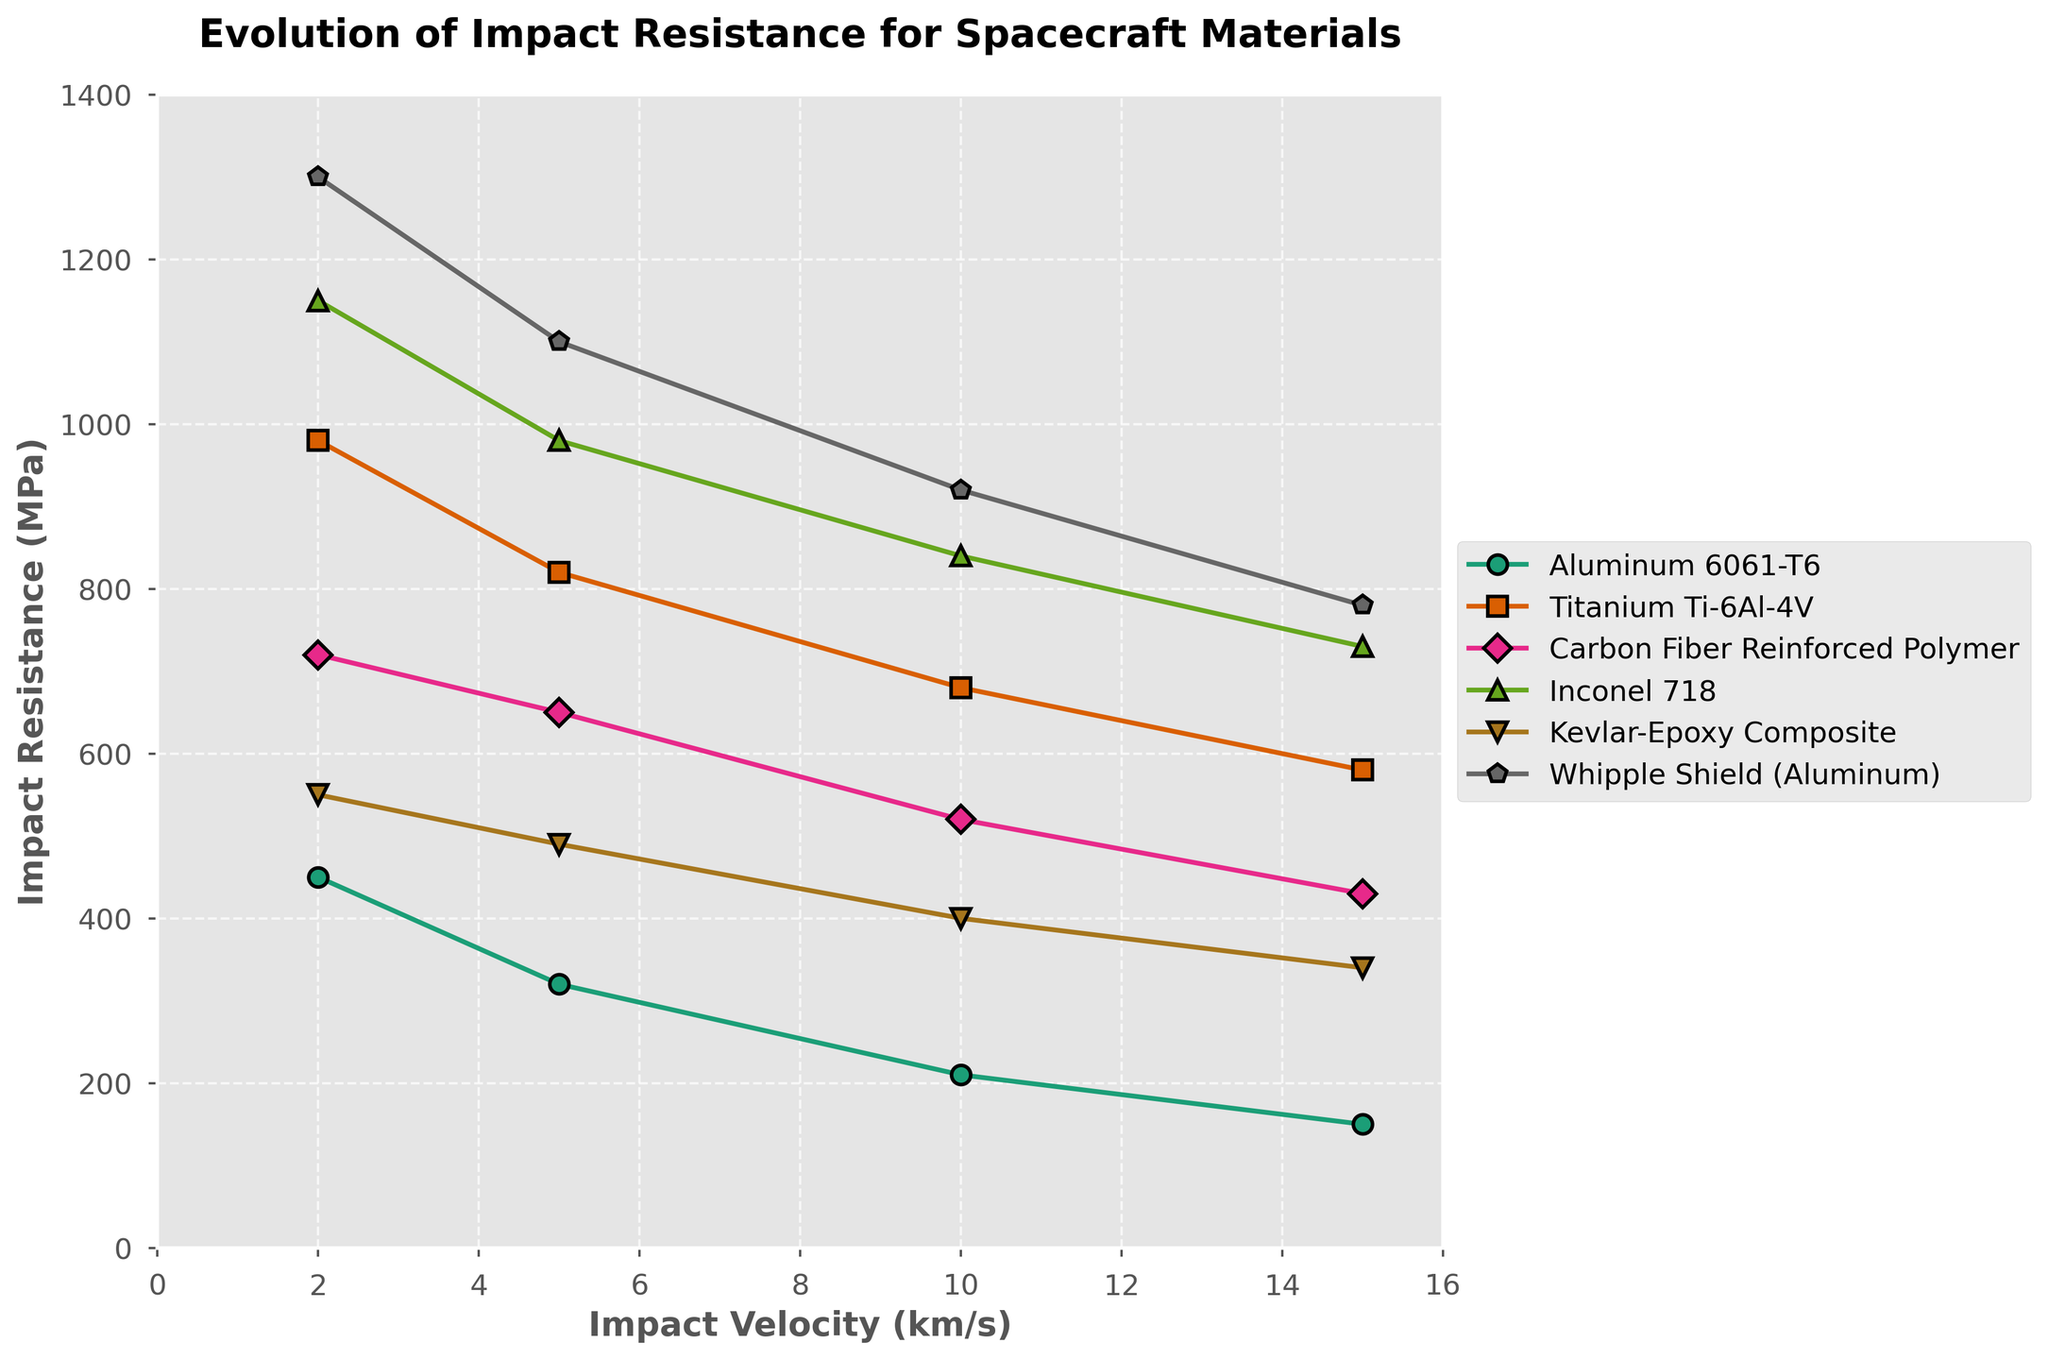What material demonstrates the highest impact resistance at 2 km/s? Look at the chart and identify the material with the highest impact resistance value at 2 km/s. The Whipple Shield (Aluminum) has the highest value at this velocity, with 1300 MPa.
Answer: Whipple Shield (Aluminum) Which material shows the steepest decline in impact resistance as velocity increases from 2 km/s to 15 km/s? Analyze the slope of the lines for each material from 2 km/s to 15 km/s. Aluminum 6061-T6 exhibits the steepest decline, dropping from 450 MPa to 150 MPa.
Answer: Aluminum 6061-T6 How does the impact resistance of Inconel 718 change from 5 km/s to 10 km/s? Look at the impact resistance values of Inconel 718 at 5 km/s and 10 km/s. It changes from 980 MPa at 5 km/s to 840 MPa at 10 km/s.
Answer: Decreases Which material has the smallest change in impact resistance from 10 km/s to 15 km/s? Compare the changes in impact resistance for all materials between 10 km/s and 15 km/s. Titanium Ti-6Al-4V shows the smallest change, decreasing from 680 MPa to 580 MPa, a difference of 100 MPa.
Answer: Titanium Ti-6Al-4V What's the average impact resistance of Carbon Fiber Reinforced Polymer across all velocities? Average the impact resistance values of Carbon Fiber Reinforced Polymer across all velocities: (720 + 650 + 520 + 430) / 4 = 580 MPa.
Answer: 580 MPa Between Titanium Ti-6Al-4V and Carbon Fiber Reinforced Polymer, which material demonstrates better impact resistance at lower velocities (2 and 5 km/s)? Identify and compare the impact resistance values at 2 km/s and 5 km/s for both materials: Titanium Ti-6Al-4V (980 MPa, 820 MPa) and Carbon Fiber Reinforced Polymer (720 MPa, 650 MPa). Titanium Ti-6Al-4V shows better impact resistance at both velocities.
Answer: Titanium Ti-6Al-4V Which material has the closest impact resistance values at 5 km/s and 10 km/s? Compare the differences in impact resistance values between 5 km/s and 10 km/s for each material: Kevlar-Epoxy Composite has the closest values with 490 MPa at 5 km/s and 400 MPa at 10 km/s, a difference of 90 MPa.
Answer: Kevlar-Epoxy Composite What is the total impact resistance of Aluminum 6061-T6 across all velocities? Sum the impact resistance values of Aluminum 6061-T6 across all velocities: 450 + 320 + 210 + 150 = 1130 MPa.
Answer: 1130 MPa Which material retains more than 50% of its impact resistance at 15 km/s compared to its value at 2 km/s? Calculate 50% of each material's impact resistance at 2 km/s and compare it to its impact resistance at 15 km/s: Inconel 718, Kevlar-Epoxy Composite, and Whipple Shield (Aluminum) retain more than 50%. For instance, Inconel 718’s 50% value at 2 km/s is 575 MPa, and it retains 730 MPa at 15 km/s.
Answer: Inconel 718, Kevlar-Epoxy Composite, Whipple Shield (Aluminum) 